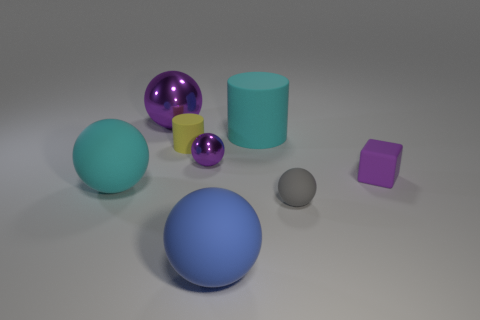Subtract 1 spheres. How many spheres are left? 4 Subtract all brown spheres. Subtract all green blocks. How many spheres are left? 5 Add 2 big cyan spheres. How many objects exist? 10 Subtract all blocks. How many objects are left? 7 Add 8 green rubber cylinders. How many green rubber cylinders exist? 8 Subtract 0 green blocks. How many objects are left? 8 Subtract all tiny red rubber blocks. Subtract all tiny gray rubber objects. How many objects are left? 7 Add 1 large cyan rubber spheres. How many large cyan rubber spheres are left? 2 